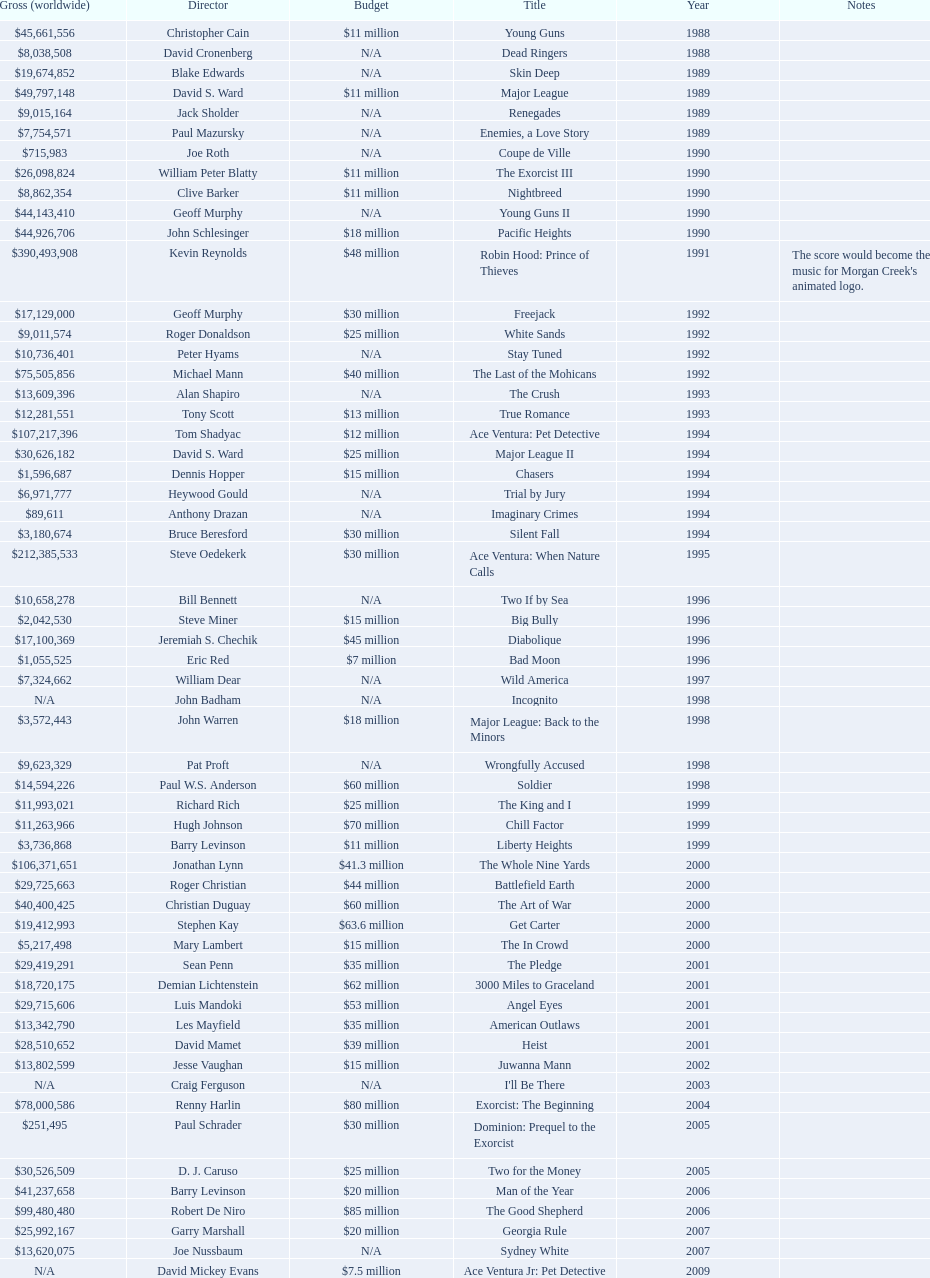What was the last movie morgan creek made for a budget under thirty million? Ace Ventura Jr: Pet Detective. 